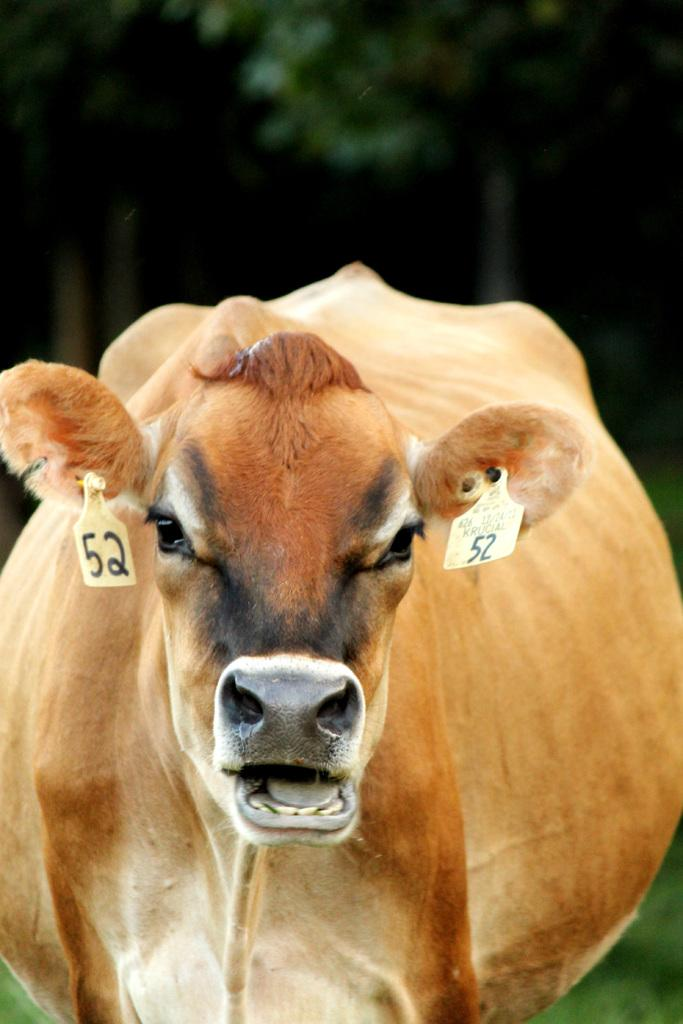What animal is present in the image? There is a cow in the image. What can be observed about the background of the image? The background of the image is dark. How many lizards are comfortably resting on the cow in the image? There are no lizards present in the image, and therefore no such activity can be observed. 